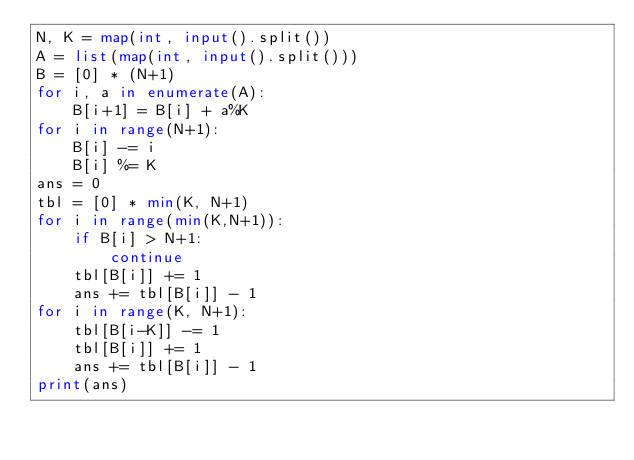<code> <loc_0><loc_0><loc_500><loc_500><_Python_>N, K = map(int, input().split())
A = list(map(int, input().split()))
B = [0] * (N+1)
for i, a in enumerate(A):
    B[i+1] = B[i] + a%K
for i in range(N+1):
    B[i] -= i
    B[i] %= K
ans = 0
tbl = [0] * min(K, N+1)
for i in range(min(K,N+1)):
    if B[i] > N+1:
        continue
    tbl[B[i]] += 1
    ans += tbl[B[i]] - 1
for i in range(K, N+1):
    tbl[B[i-K]] -= 1
    tbl[B[i]] += 1
    ans += tbl[B[i]] - 1
print(ans)
</code> 